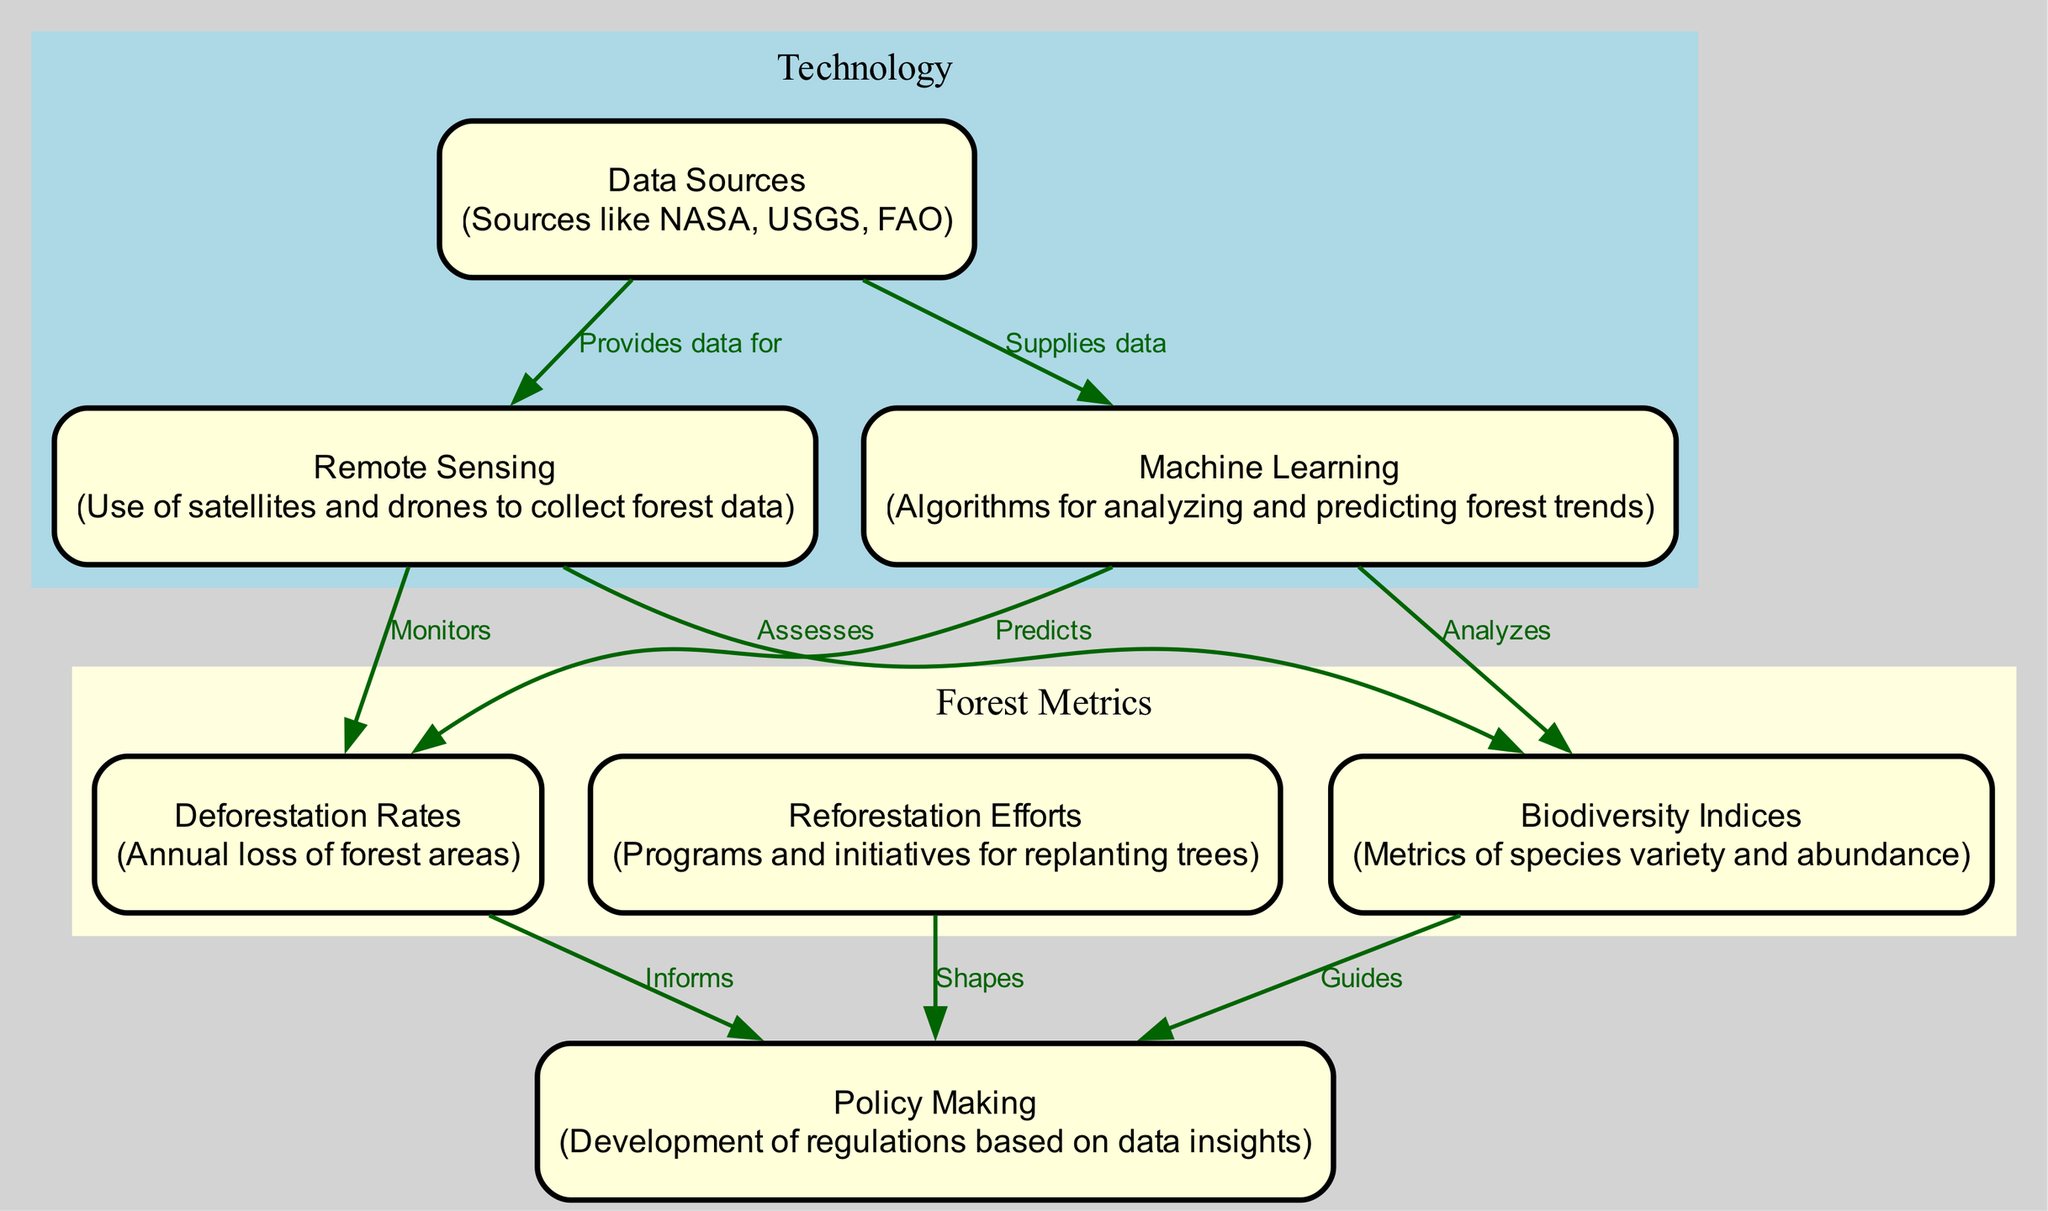What is the main purpose of Remote Sensing? Remote Sensing is indicated in the diagram as a means to "Monitor" Deforestation Rates and "Assess" Biodiversity Indices. Thus, its main purpose is to gather data regarding these forest metrics.
Answer: Monitor How is Machine Learning connected to Biodiversity Indices? The diagram shows that Machine Learning "Analyzes" Biodiversity Indices. This indicates that there is a direct relationship where machine learning techniques are applied to understand biodiversity data.
Answer: Analyzes How many edges are connecting the nodes? By counting the edges listed in the diagram, there is a total of 9 relationships (edges) that connect the different nodes.
Answer: 9 Which node shapes the Policy Making? According to the diagram, the node "Reforestation Efforts" is specifically labeled as shaping Policy Making. This shows its influence in the decision-making process regarding forest conservation.
Answer: Shapes What role do Data Sources play in relation to Remote Sensing? The diagram indicates that Data Sources "Provides data for" Remote Sensing. Thus, they supply essential information that Remote Sensing utilizes to monitor forest conditions.
Answer: Provides data for What are the two roles of Machine Learning as depicted in the diagram? The diagram illustrates two specific functions of Machine Learning: it "Predicts" Deforestation Rates and "Analyzes" Biodiversity Indices. These roles contribute to understanding and forecasting forest changes.
Answer: Predicts and Analyzes Which element guides Policy Making based on the diagram? The diagram specifies that the Biodiversity Indices "Guides" Policy Making, indicating that data on biodiversity plays a crucial role in shaping policies for forest conservation.
Answer: Guides How is the Deforestation Rates node visually portrayed in the diagram? The Deforestation Rates node is connected to multiple edges and has arrows indicating the flow of influence, specifically informing Policy Making through its relationships to various other nodes.
Answer: Connected to multiple edges What does Reforestation Efforts node indicate in its relationship to Policy Making? The diagram indicates that Reforestation Efforts has a direct relationship with Policy Making, labeled as "Shapes". This signifies that these efforts influence the development of conservation regulations and policies.
Answer: Shapes 